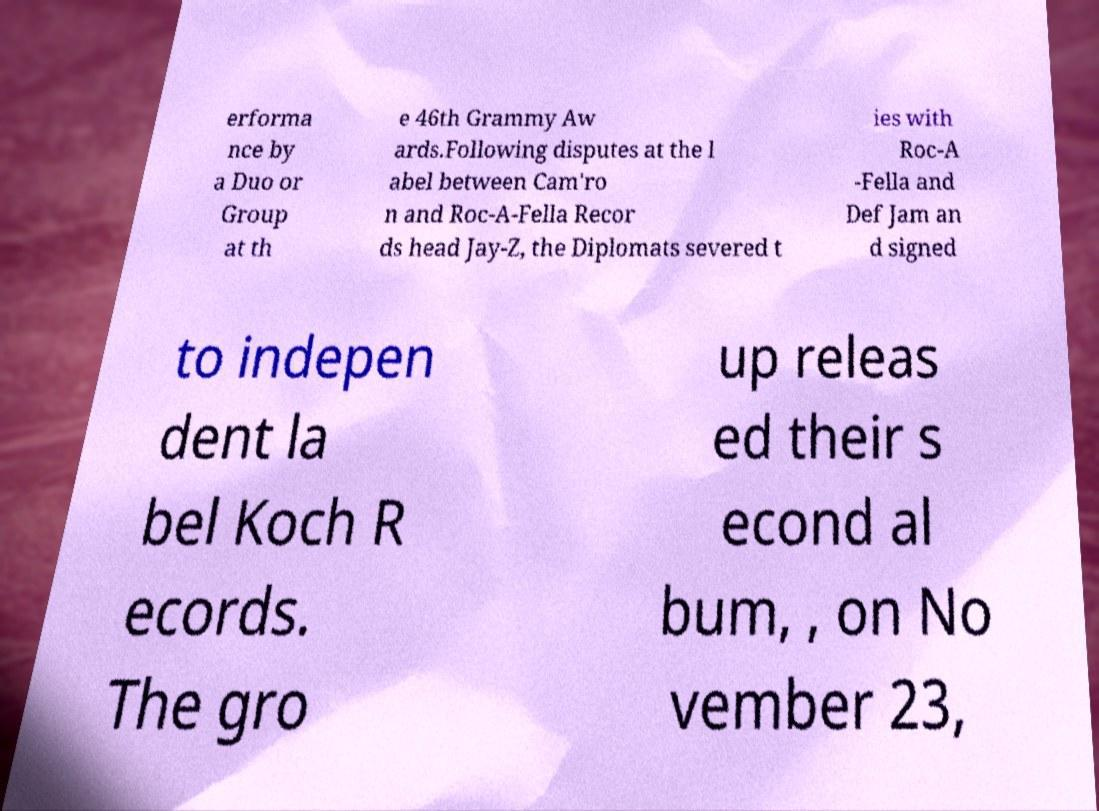Can you accurately transcribe the text from the provided image for me? erforma nce by a Duo or Group at th e 46th Grammy Aw ards.Following disputes at the l abel between Cam'ro n and Roc-A-Fella Recor ds head Jay-Z, the Diplomats severed t ies with Roc-A -Fella and Def Jam an d signed to indepen dent la bel Koch R ecords. The gro up releas ed their s econd al bum, , on No vember 23, 